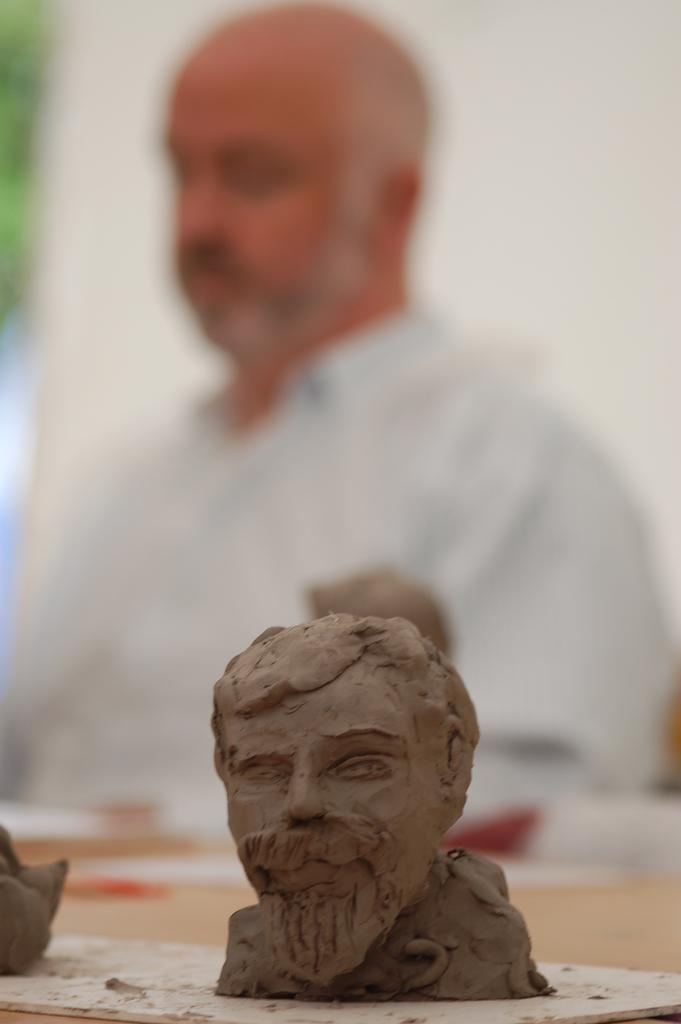What is the main object on the table in the image? There is an idol made with mud on the table. What else can be seen on the table? The facts provided do not mention any other objects on the table. Can you describe the man in the background of the image? The man is in the background of the image, and he is wearing a shirt. What is the man doing in the image? The facts provided do not mention what the man is doing in the image. What type of vessel is being used to transport the cake in the image? There is no vessel or cake present in the image. 